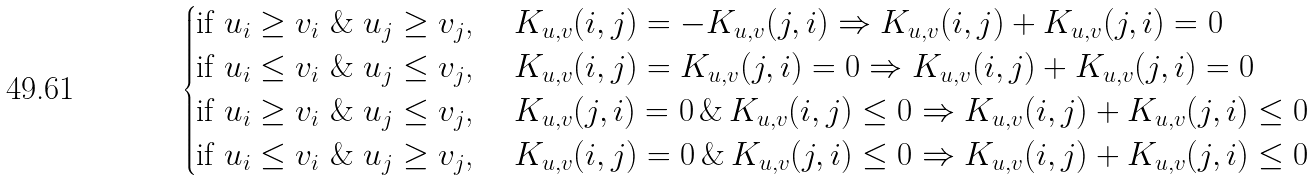Convert formula to latex. <formula><loc_0><loc_0><loc_500><loc_500>\begin{cases} \text {if } u _ { i } \geq v _ { i } \ \& \ u _ { j } \geq v _ { j } \text {, \quad} K _ { u , v } ( i , j ) = - K _ { u , v } ( j , i ) \Rightarrow K _ { u , v } ( i , j ) + K _ { u , v } ( j , i ) = 0 \\ \text {if } u _ { i } \leq v _ { i } \ \& \ u _ { j } \leq v _ { j } \text {, \quad} K _ { u , v } ( i , j ) = K _ { u , v } ( j , i ) = 0 \Rightarrow K _ { u , v } ( i , j ) + K _ { u , v } ( j , i ) = 0 \\ \text {if } u _ { i } \geq v _ { i } \ \& \ u _ { j } \leq v _ { j } \text {, \quad} K _ { u , v } ( j , i ) = 0 \, \& \, K _ { u , v } ( i , j ) \leq 0 \Rightarrow K _ { u , v } ( i , j ) + K _ { u , v } ( j , i ) \leq 0 \\ \text {if } u _ { i } \leq v _ { i } \ \& \ u _ { j } \geq v _ { j } \text {, \quad} K _ { u , v } ( i , j ) = 0 \, \& \, K _ { u , v } ( j , i ) \leq 0 \Rightarrow K _ { u , v } ( i , j ) + K _ { u , v } ( j , i ) \leq 0 \end{cases}</formula> 